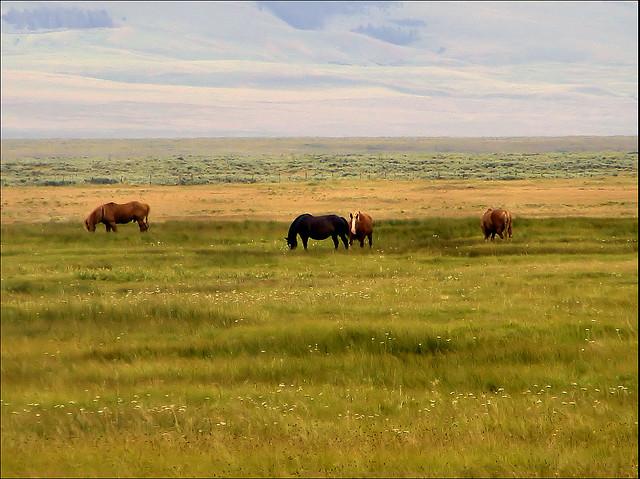Which creature is not like the other ones?
Be succinct. Black one. Is this a flat land?
Be succinct. Yes. Are there trees in this photo?
Answer briefly. No. Was this taken in the desert?
Write a very short answer. No. Is the grass lush?
Be succinct. Yes. How many animals?
Give a very brief answer. 4. What color are the mountains?
Be succinct. Brown. 